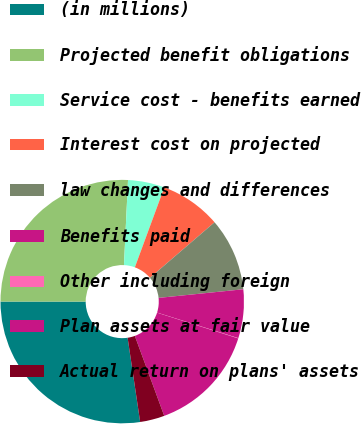<chart> <loc_0><loc_0><loc_500><loc_500><pie_chart><fcel>(in millions)<fcel>Projected benefit obligations<fcel>Service cost - benefits earned<fcel>Interest cost on projected<fcel>law changes and differences<fcel>Benefits paid<fcel>Other including foreign<fcel>Plan assets at fair value<fcel>Actual return on plans' assets<nl><fcel>27.36%<fcel>25.75%<fcel>4.86%<fcel>8.08%<fcel>9.68%<fcel>6.47%<fcel>0.04%<fcel>14.5%<fcel>3.25%<nl></chart> 